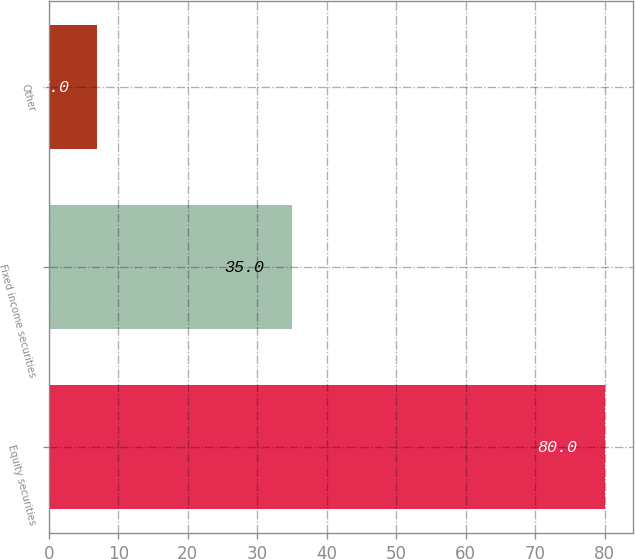<chart> <loc_0><loc_0><loc_500><loc_500><bar_chart><fcel>Equity securities<fcel>Fixed income securities<fcel>Other<nl><fcel>80<fcel>35<fcel>7<nl></chart> 